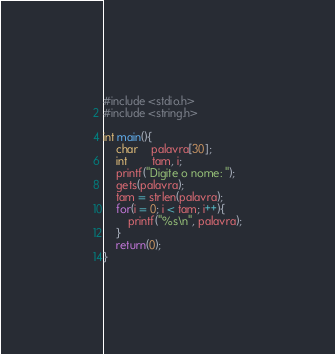<code> <loc_0><loc_0><loc_500><loc_500><_C_>#include <stdio.h>
#include <string.h>

int main(){
	char	palavra[30];
	int		tam, i;
	printf("Digite o nome: ");
	gets(palavra);
	tam = strlen(palavra);
	for(i = 0; i < tam; i++){
		printf("%s\n", palavra);
	}
	return(0);
}
</code> 